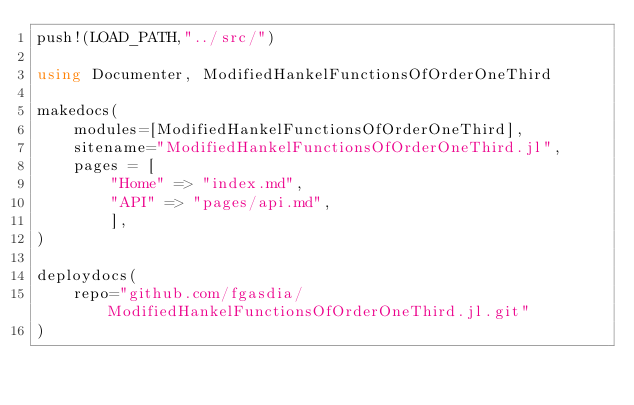<code> <loc_0><loc_0><loc_500><loc_500><_Julia_>push!(LOAD_PATH,"../src/")

using Documenter, ModifiedHankelFunctionsOfOrderOneThird

makedocs(
    modules=[ModifiedHankelFunctionsOfOrderOneThird],
    sitename="ModifiedHankelFunctionsOfOrderOneThird.jl",
    pages = [
        "Home" => "index.md",
        "API" => "pages/api.md",
        ],
)

deploydocs(
    repo="github.com/fgasdia/ModifiedHankelFunctionsOfOrderOneThird.jl.git"
)
</code> 